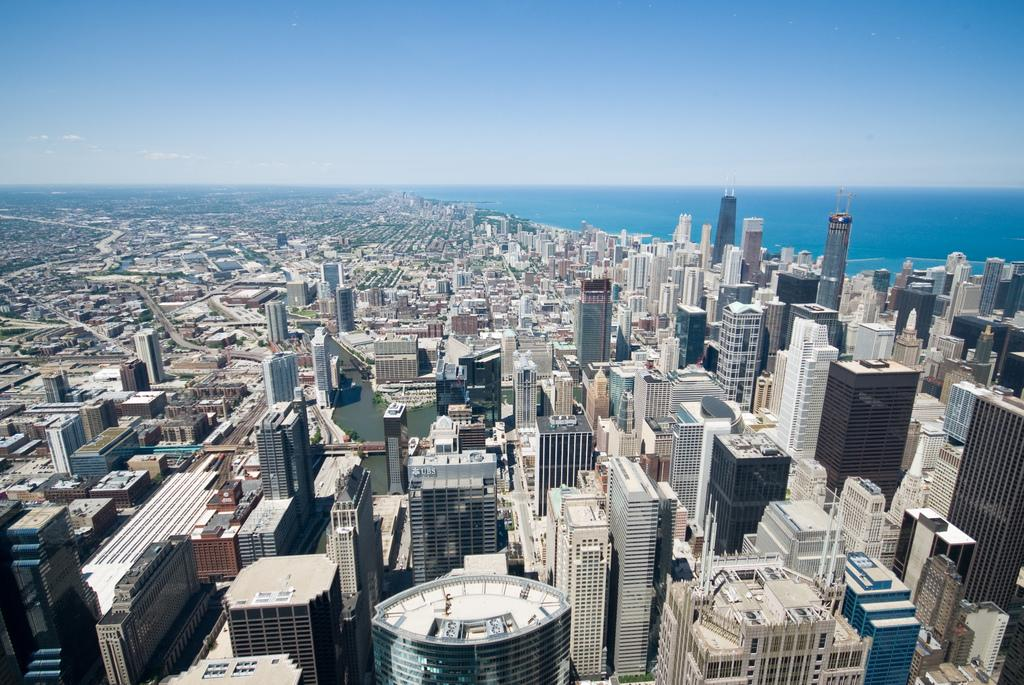What type of view is shown in the image? The image is an aerial view. What structures can be seen in the image? There are buildings and towers in the image. What natural feature is visible in the image? There is a sea visible in the image. What else can be seen in the sky in the image? The sky is visible in the image. What is the position of the feeling in the image? There is no feeling present in the image; it is a photograph of an aerial view of buildings, towers, sea, and sky. 